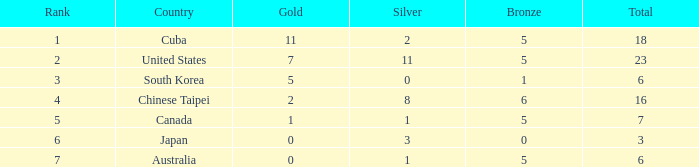What is the smallest total medals count for the united states who acquired over 11 silver medals? None. 